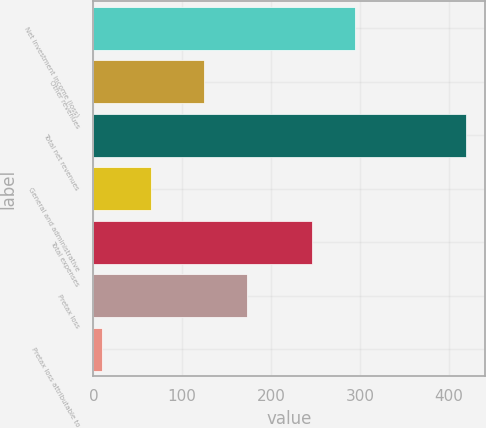Convert chart. <chart><loc_0><loc_0><loc_500><loc_500><bar_chart><fcel>Net investment income (loss)<fcel>Other revenues<fcel>Total net revenues<fcel>General and administrative<fcel>Total expenses<fcel>Pretax loss<fcel>Pretax loss attributable to<nl><fcel>294<fcel>125<fcel>419<fcel>65<fcel>246<fcel>173<fcel>10<nl></chart> 